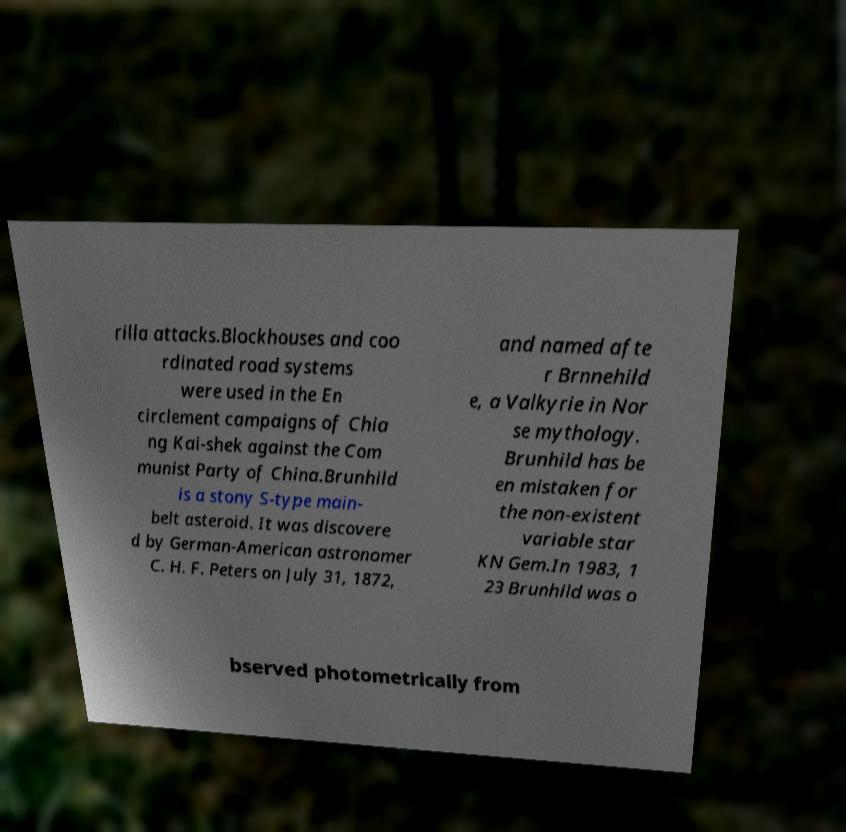There's text embedded in this image that I need extracted. Can you transcribe it verbatim? rilla attacks.Blockhouses and coo rdinated road systems were used in the En circlement campaigns of Chia ng Kai-shek against the Com munist Party of China.Brunhild is a stony S-type main- belt asteroid. It was discovere d by German-American astronomer C. H. F. Peters on July 31, 1872, and named afte r Brnnehild e, a Valkyrie in Nor se mythology. Brunhild has be en mistaken for the non-existent variable star KN Gem.In 1983, 1 23 Brunhild was o bserved photometrically from 